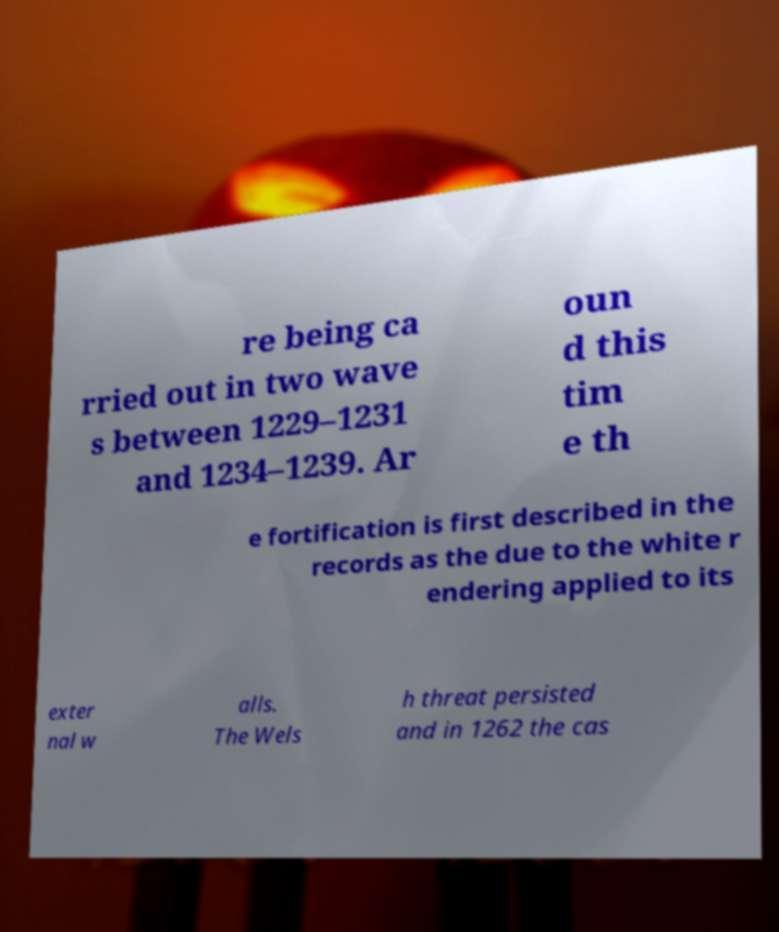For documentation purposes, I need the text within this image transcribed. Could you provide that? re being ca rried out in two wave s between 1229–1231 and 1234–1239. Ar oun d this tim e th e fortification is first described in the records as the due to the white r endering applied to its exter nal w alls. The Wels h threat persisted and in 1262 the cas 